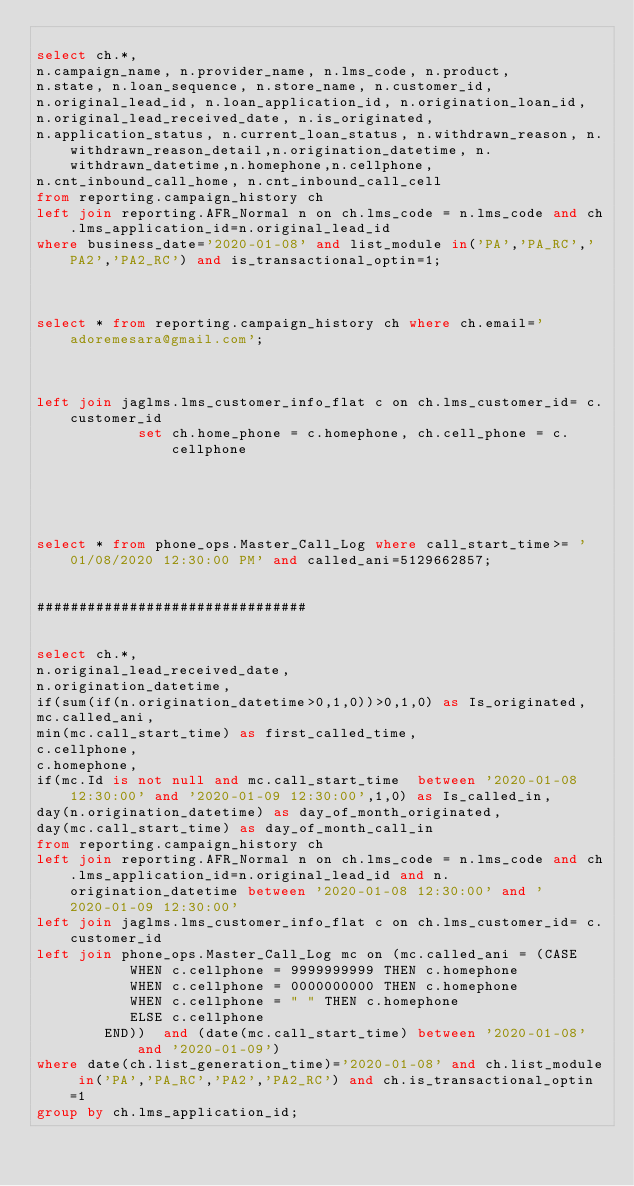<code> <loc_0><loc_0><loc_500><loc_500><_SQL_>
select ch.*,
n.campaign_name, n.provider_name, n.lms_code, n.product,
n.state, n.loan_sequence, n.store_name, n.customer_id,
n.original_lead_id, n.loan_application_id, n.origination_loan_id,
n.original_lead_received_date, n.is_originated,
n.application_status, n.current_loan_status, n.withdrawn_reason, n.withdrawn_reason_detail,n.origination_datetime, n.withdrawn_datetime,n.homephone,n.cellphone,
n.cnt_inbound_call_home, n.cnt_inbound_call_cell
from reporting.campaign_history ch
left join reporting.AFR_Normal n on ch.lms_code = n.lms_code and ch.lms_application_id=n.original_lead_id
where business_date='2020-01-08' and list_module in('PA','PA_RC','PA2','PA2_RC') and is_transactional_optin=1;



select * from reporting.campaign_history ch where ch.email='adoremesara@gmail.com';



left join jaglms.lms_customer_info_flat c on ch.lms_customer_id= c.customer_id
            set ch.home_phone = c.homephone, ch.cell_phone = c.cellphone





select * from phone_ops.Master_Call_Log where call_start_time>= '01/08/2020 12:30:00 PM' and called_ani=5129662857;


################################


select ch.*, 
n.original_lead_received_date,
n.origination_datetime,
if(sum(if(n.origination_datetime>0,1,0))>0,1,0) as Is_originated,
mc.called_ani,
min(mc.call_start_time) as first_called_time,
c.cellphone,
c.homephone,
if(mc.Id is not null and mc.call_start_time  between '2020-01-08 12:30:00' and '2020-01-09 12:30:00',1,0) as Is_called_in,
day(n.origination_datetime) as day_of_month_originated,
day(mc.call_start_time) as day_of_month_call_in
from reporting.campaign_history ch
left join reporting.AFR_Normal n on ch.lms_code = n.lms_code and ch.lms_application_id=n.original_lead_id and n.origination_datetime between '2020-01-08 12:30:00' and '2020-01-09 12:30:00' 
left join jaglms.lms_customer_info_flat c on ch.lms_customer_id= c.customer_id
left join phone_ops.Master_Call_Log mc on (mc.called_ani = (CASE
           WHEN c.cellphone = 9999999999 THEN c.homephone
           WHEN c.cellphone = 0000000000 THEN c.homephone
           WHEN c.cellphone = " " THEN c.homephone
           ELSE c.cellphone
        END))  and (date(mc.call_start_time) between '2020-01-08'  and '2020-01-09')
where date(ch.list_generation_time)='2020-01-08' and ch.list_module in('PA','PA_RC','PA2','PA2_RC') and ch.is_transactional_optin=1
group by ch.lms_application_id;

</code> 